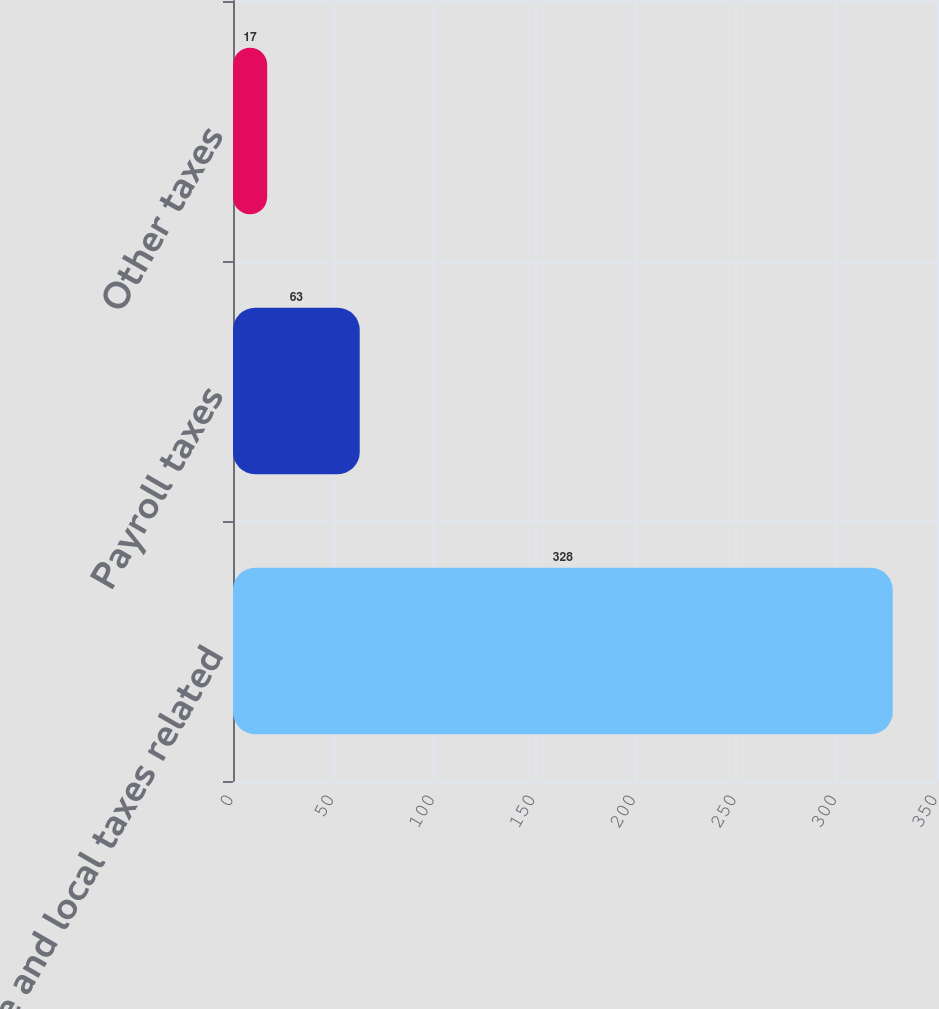<chart> <loc_0><loc_0><loc_500><loc_500><bar_chart><fcel>State and local taxes related<fcel>Payroll taxes<fcel>Other taxes<nl><fcel>328<fcel>63<fcel>17<nl></chart> 